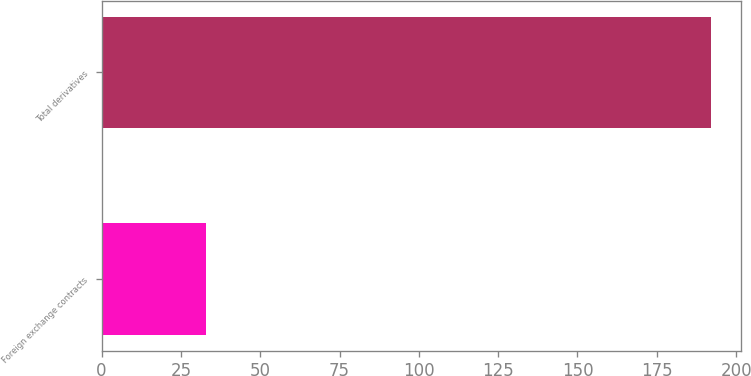Convert chart. <chart><loc_0><loc_0><loc_500><loc_500><bar_chart><fcel>Foreign exchange contracts<fcel>Total derivatives<nl><fcel>33<fcel>192<nl></chart> 